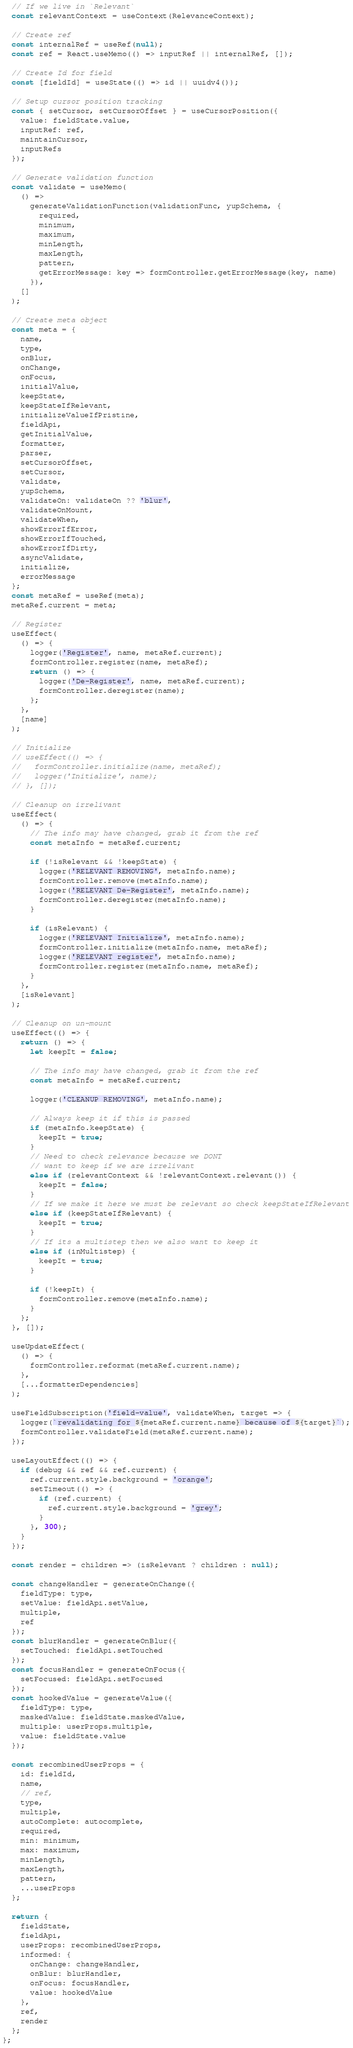<code> <loc_0><loc_0><loc_500><loc_500><_JavaScript_>
  // If we live in `Relevant`
  const relevantContext = useContext(RelevanceContext);

  // Create ref
  const internalRef = useRef(null);
  const ref = React.useMemo(() => inputRef || internalRef, []);

  // Create Id for field
  const [fieldId] = useState(() => id || uuidv4());

  // Setup cursor position tracking
  const { setCursor, setCursorOffset } = useCursorPosition({
    value: fieldState.value,
    inputRef: ref,
    maintainCursor,
    inputRefs
  });

  // Generate validation function
  const validate = useMemo(
    () =>
      generateValidationFunction(validationFunc, yupSchema, {
        required,
        minimum,
        maximum,
        minLength,
        maxLength,
        pattern,
        getErrorMessage: key => formController.getErrorMessage(key, name)
      }),
    []
  );

  // Create meta object
  const meta = {
    name,
    type,
    onBlur,
    onChange,
    onFocus,
    initialValue,
    keepState,
    keepStateIfRelevant,
    initializeValueIfPristine,
    fieldApi,
    getInitialValue,
    formatter,
    parser,
    setCursorOffset,
    setCursor,
    validate,
    yupSchema,
    validateOn: validateOn ?? 'blur',
    validateOnMount,
    validateWhen,
    showErrorIfError,
    showErrorIfTouched,
    showErrorIfDirty,
    asyncValidate,
    initialize,
    errorMessage
  };
  const metaRef = useRef(meta);
  metaRef.current = meta;

  // Register
  useEffect(
    () => {
      logger('Register', name, metaRef.current);
      formController.register(name, metaRef);
      return () => {
        logger('De-Register', name, metaRef.current);
        formController.deregister(name);
      };
    },
    [name]
  );

  // Initialize
  // useEffect(() => {
  //   formController.initialize(name, metaRef);
  //   logger('Initialize', name);
  // }, []);

  // Cleanup on irrelivant
  useEffect(
    () => {
      // The info may have changed, grab it from the ref
      const metaInfo = metaRef.current;

      if (!isRelevant && !keepState) {
        logger('RELEVANT REMOVING', metaInfo.name);
        formController.remove(metaInfo.name);
        logger('RELEVANT De-Register', metaInfo.name);
        formController.deregister(metaInfo.name);
      }

      if (isRelevant) {
        logger('RELEVANT Initialize', metaInfo.name);
        formController.initialize(metaInfo.name, metaRef);
        logger('RELEVANT register', metaInfo.name);
        formController.register(metaInfo.name, metaRef);
      }
    },
    [isRelevant]
  );

  // Cleanup on un-mount
  useEffect(() => {
    return () => {
      let keepIt = false;

      // The info may have changed, grab it from the ref
      const metaInfo = metaRef.current;

      logger('CLEANUP REMOVING', metaInfo.name);

      // Always keep it if this is passed
      if (metaInfo.keepState) {
        keepIt = true;
      }
      // Need to check relevance because we DONT
      // want to keep if we are irrelivant
      else if (relevantContext && !relevantContext.relevant()) {
        keepIt = false;
      }
      // If we make it here we must be relevant so check keepStateIfRelevant
      else if (keepStateIfRelevant) {
        keepIt = true;
      }
      // If its a multistep then we also want to keep it
      else if (inMultistep) {
        keepIt = true;
      }

      if (!keepIt) {
        formController.remove(metaInfo.name);
      }
    };
  }, []);

  useUpdateEffect(
    () => {
      formController.reformat(metaRef.current.name);
    },
    [...formatterDependencies]
  );

  useFieldSubscription('field-value', validateWhen, target => {
    logger(`revalidating for ${metaRef.current.name} because of ${target}`);
    formController.validateField(metaRef.current.name);
  });

  useLayoutEffect(() => {
    if (debug && ref && ref.current) {
      ref.current.style.background = 'orange';
      setTimeout(() => {
        if (ref.current) {
          ref.current.style.background = 'grey';
        }
      }, 300);
    }
  });

  const render = children => (isRelevant ? children : null);

  const changeHandler = generateOnChange({
    fieldType: type,
    setValue: fieldApi.setValue,
    multiple,
    ref
  });
  const blurHandler = generateOnBlur({
    setTouched: fieldApi.setTouched
  });
  const focusHandler = generateOnFocus({
    setFocused: fieldApi.setFocused
  });
  const hookedValue = generateValue({
    fieldType: type,
    maskedValue: fieldState.maskedValue,
    multiple: userProps.multiple,
    value: fieldState.value
  });

  const recombinedUserProps = {
    id: fieldId,
    name,
    // ref,
    type,
    multiple,
    autoComplete: autocomplete,
    required,
    min: minimum,
    max: maximum,
    minLength,
    maxLength,
    pattern,
    ...userProps
  };

  return {
    fieldState,
    fieldApi,
    userProps: recombinedUserProps,
    informed: {
      onChange: changeHandler,
      onBlur: blurHandler,
      onFocus: focusHandler,
      value: hookedValue
    },
    ref,
    render
  };
};
</code> 